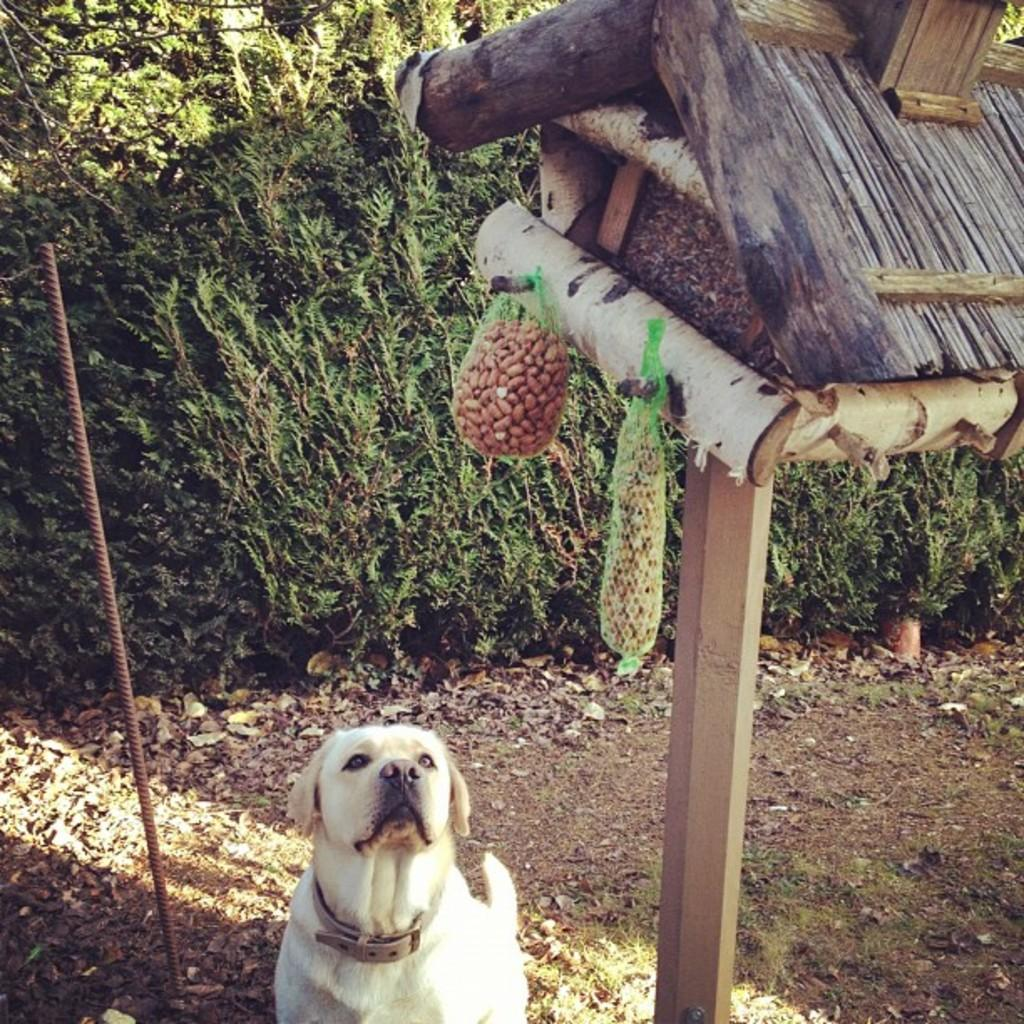What type of animal is in the image? There is a white color dog in the image. What is located beside the dog? There is a metal rod beside the dog. What can be seen in the background or surrounding the dog? There are plants visible in the image. What type of egg is being transported on the railway in the image? There is no railway or egg present in the image. 